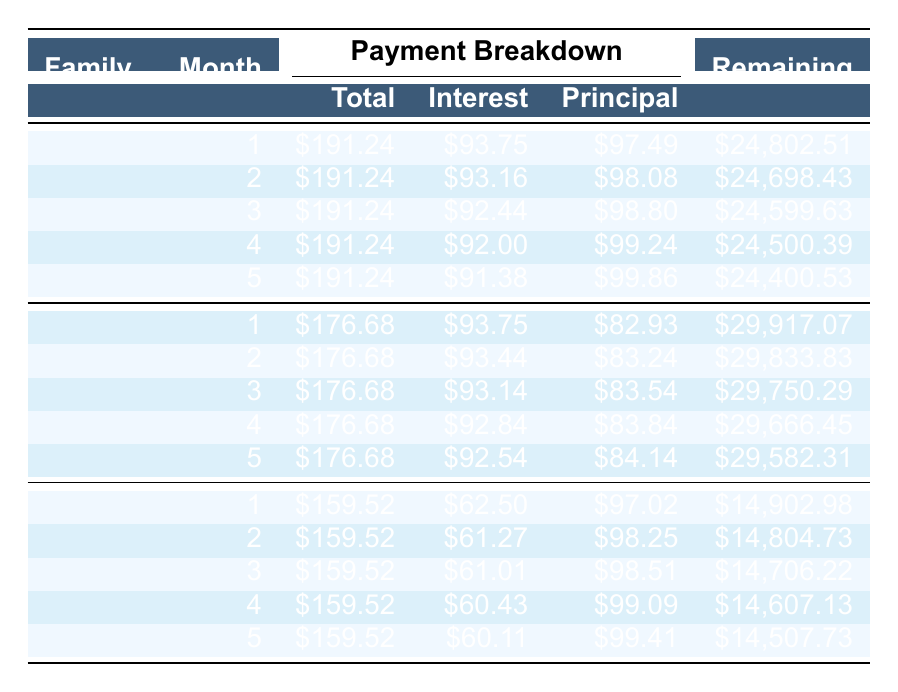What is the loan amount for the Smith Family? The loan amount for the Smith Family is directly mentioned in the table under the "loan_amount" column. The value is $25,000.
Answer: 25000 How much is the monthly payment for the Garcia Family? The monthly payment for the Garcia Family is found under the "monthly_payment" column, where it lists the value as $176.68.
Answer: 176.68 What is the total principal paid in the first month by the Nguyen Family? The principal paid in the first month by the Nguyen Family can be seen in the first row for Nguyen under the "Principal" column, which shows $97.02.
Answer: 97.02 Which family has the highest interest payment in the first month? To determine which family has the highest interest payment in the first month, we look at the "Interest" column in the first month for all families. The Smith Family has an interest payment of $93.75, Garcia Family also has $93.75, and Nguyen Family has $62.50; thus, the highest among these is $93.75 by both the Smith and Garcia Families.
Answer: Smith and Garcia Families What is the remaining balance for the Garcia Family after the second month? The remaining balance after the second month for the Garcia Family can be found in the second month row under the "Remaining" column, which shows $29,833.83.
Answer: 29833.83 How much total has the Nguyen Family paid towards principal after the first five months? To find the total principal paid by the Nguyen Family over the first five months, we sum the principal payments listed in the payment schedule: $97.02 + $98.25 + $98.51 + $99.09 + $99.41 = $492.28. Therefore, the total principal paid after five months is $492.28.
Answer: 492.28 Is the interest rate for the Smith Family higher than that for the Garcia Family? The interest rate for the Smith Family is 4.5% and for the Garcia Family is 3.75%. Since 4.5% is greater than 3.75%, the statement is true.
Answer: Yes What is the average monthly payment across all three families? The average monthly payment can be calculated by summing the monthly payments: $191.24 (Smith) + $176.68 (Garcia) + $159.52 (Nguyen) = $527.44. Then, divide by the number of families, which is 3. Therefore, the average monthly payment is $527.44 / 3 = $175.81.
Answer: 175.81 At what month does the Smith Family reach a remaining balance of below $24,000? To determine when the Smith Family's remaining balance falls below $24,000, we check each month's remaining balance: Month 1 is $24,802.51, Month 2 is $24,698.43, Month 3 is $24,599.63, Month 4 is $24,500.39, Month 5 is $24,400.53. Therefore, it does not drop below $24,000 until after month 5, which would happen in subsequent months.
Answer: Not within first five months 